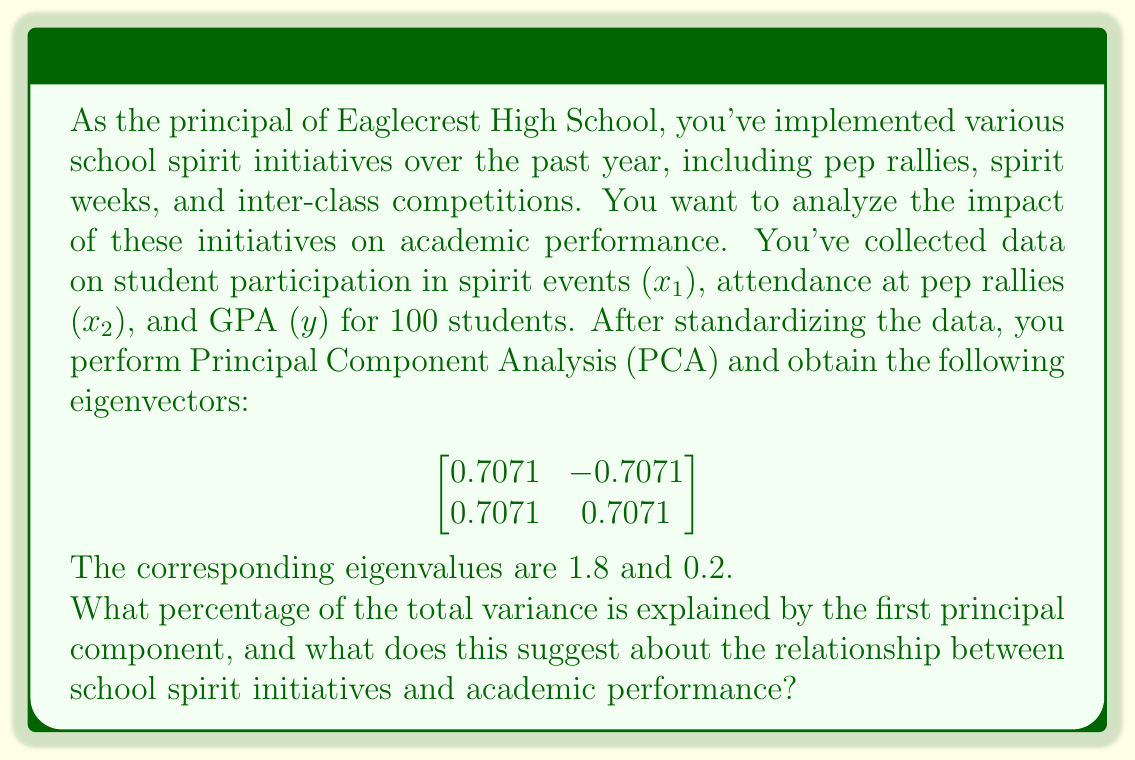Can you solve this math problem? To solve this problem, we need to follow these steps:

1) In PCA, the proportion of variance explained by each principal component is calculated by dividing its eigenvalue by the sum of all eigenvalues.

2) The sum of the eigenvalues:
   $1.8 + 0.2 = 2$

3) The proportion of variance explained by the first principal component:
   $$\frac{\text{First eigenvalue}}{\text{Sum of all eigenvalues}} = \frac{1.8}{2} = 0.9$$

4) To convert to a percentage, multiply by 100:
   $0.9 * 100 = 90\%$

5) Interpretation:
   - The first principal component explains 90% of the total variance in the data.
   - This high percentage suggests a strong correlation between the variables.
   - The eigenvector for the first principal component (0.7071, 0.7071) shows equal positive weights for both spirit initiatives variables.
   - This indicates that both types of spirit initiatives (general participation and pep rally attendance) are positively associated with each other and with academic performance (GPA).

Therefore, the analysis suggests a strong positive relationship between school spirit initiatives and academic performance. As the principal, this data supports the value of continuing and potentially expanding these initiatives to boost both school spirit and academic achievement.
Answer: The first principal component explains 90% of the total variance. This high percentage suggests a strong positive relationship between school spirit initiatives and academic performance. 